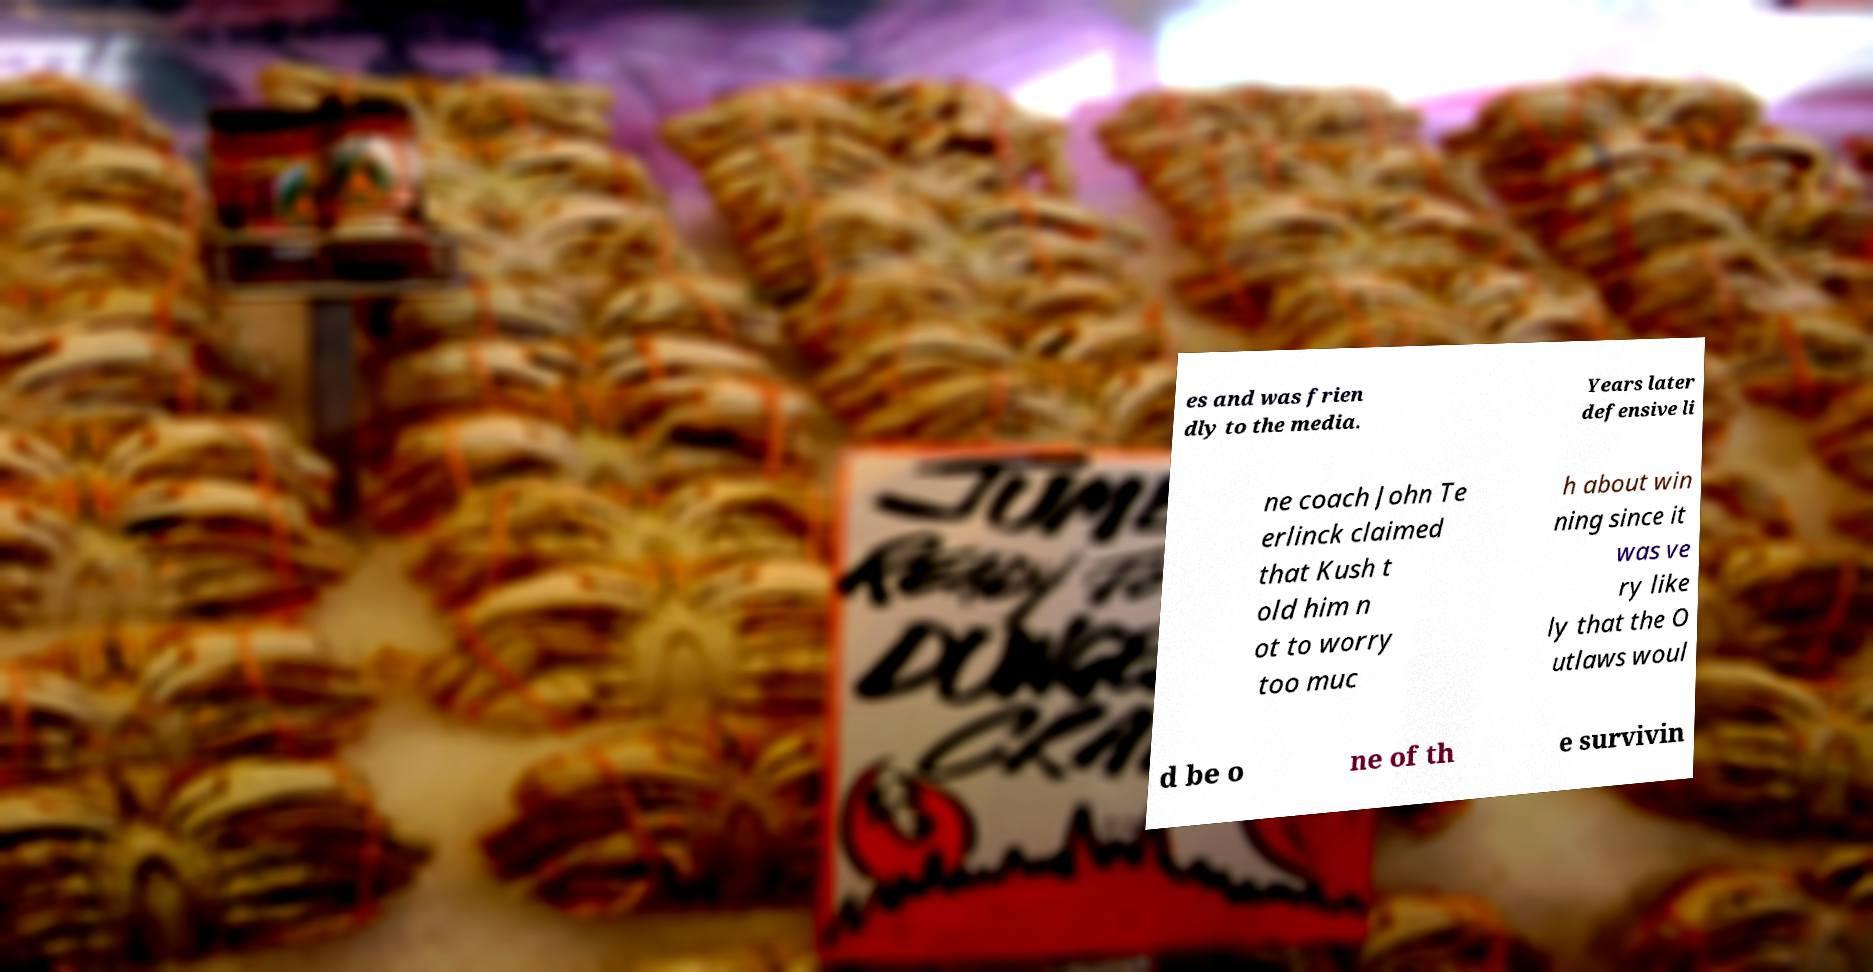There's text embedded in this image that I need extracted. Can you transcribe it verbatim? es and was frien dly to the media. Years later defensive li ne coach John Te erlinck claimed that Kush t old him n ot to worry too muc h about win ning since it was ve ry like ly that the O utlaws woul d be o ne of th e survivin 